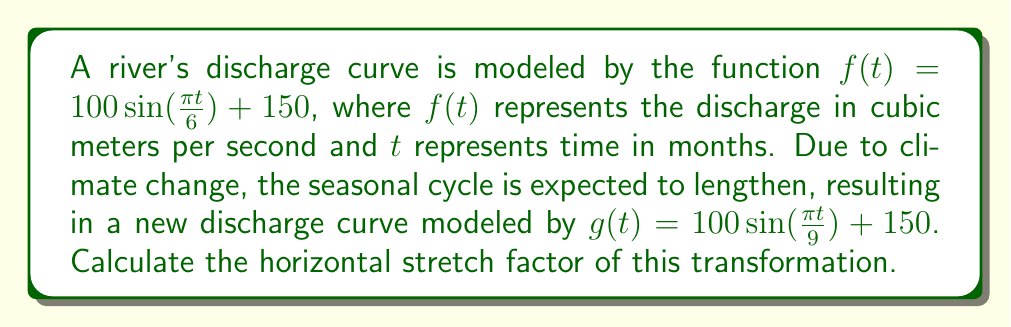Provide a solution to this math problem. To determine the horizontal stretch factor, we need to compare the periods of the two sinusoidal functions:

1) For $f(t) = 100 \sin(\frac{\pi t}{6}) + 150$:
   The period is given by $\frac{2\pi}{|\frac{\pi}{6}|} = 12$ months

2) For $g(t) = 100 \sin(\frac{\pi t}{9}) + 150$:
   The period is given by $\frac{2\pi}{|\frac{\pi}{9}|} = 18$ months

The horizontal stretch factor is the ratio of the new period to the original period:

$$\text{Stretch factor} = \frac{\text{New period}}{\text{Original period}} = \frac{18}{12} = \frac{3}{2} = 1.5$$

This means that the new function $g(t)$ is a horizontal stretch of $f(t)$ by a factor of 1.5.

Alternatively, we can observe that the argument of the sine function has changed from $\frac{\pi t}{6}$ to $\frac{\pi t}{9}$. The ratio of these coefficients also gives us the stretch factor:

$$\frac{6}{9} = \frac{2}{3}$$

The reciprocal of this ratio, $\frac{3}{2} = 1.5$, is the horizontal stretch factor.
Answer: The horizontal stretch factor is 1.5. 